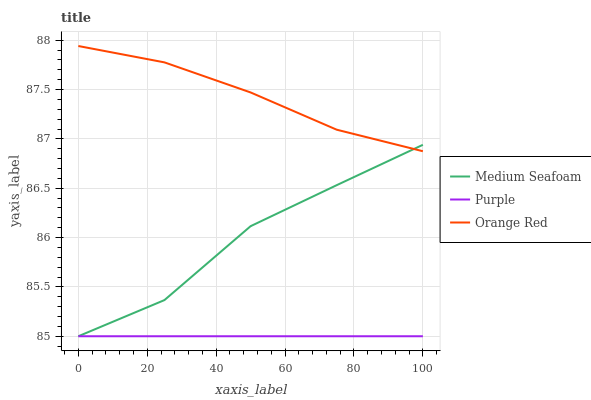Does Purple have the minimum area under the curve?
Answer yes or no. Yes. Does Orange Red have the maximum area under the curve?
Answer yes or no. Yes. Does Medium Seafoam have the minimum area under the curve?
Answer yes or no. No. Does Medium Seafoam have the maximum area under the curve?
Answer yes or no. No. Is Purple the smoothest?
Answer yes or no. Yes. Is Medium Seafoam the roughest?
Answer yes or no. Yes. Is Orange Red the smoothest?
Answer yes or no. No. Is Orange Red the roughest?
Answer yes or no. No. Does Orange Red have the lowest value?
Answer yes or no. No. Does Medium Seafoam have the highest value?
Answer yes or no. No. Is Purple less than Orange Red?
Answer yes or no. Yes. Is Orange Red greater than Purple?
Answer yes or no. Yes. Does Purple intersect Orange Red?
Answer yes or no. No. 